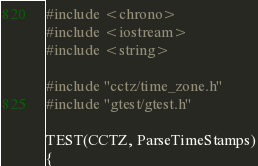Convert code to text. <code><loc_0><loc_0><loc_500><loc_500><_C++_>#include <chrono>
#include <iostream>
#include <string>

#include "cctz/time_zone.h"
#include "gtest/gtest.h"

TEST(CCTZ, ParseTimeStamps)
{</code> 